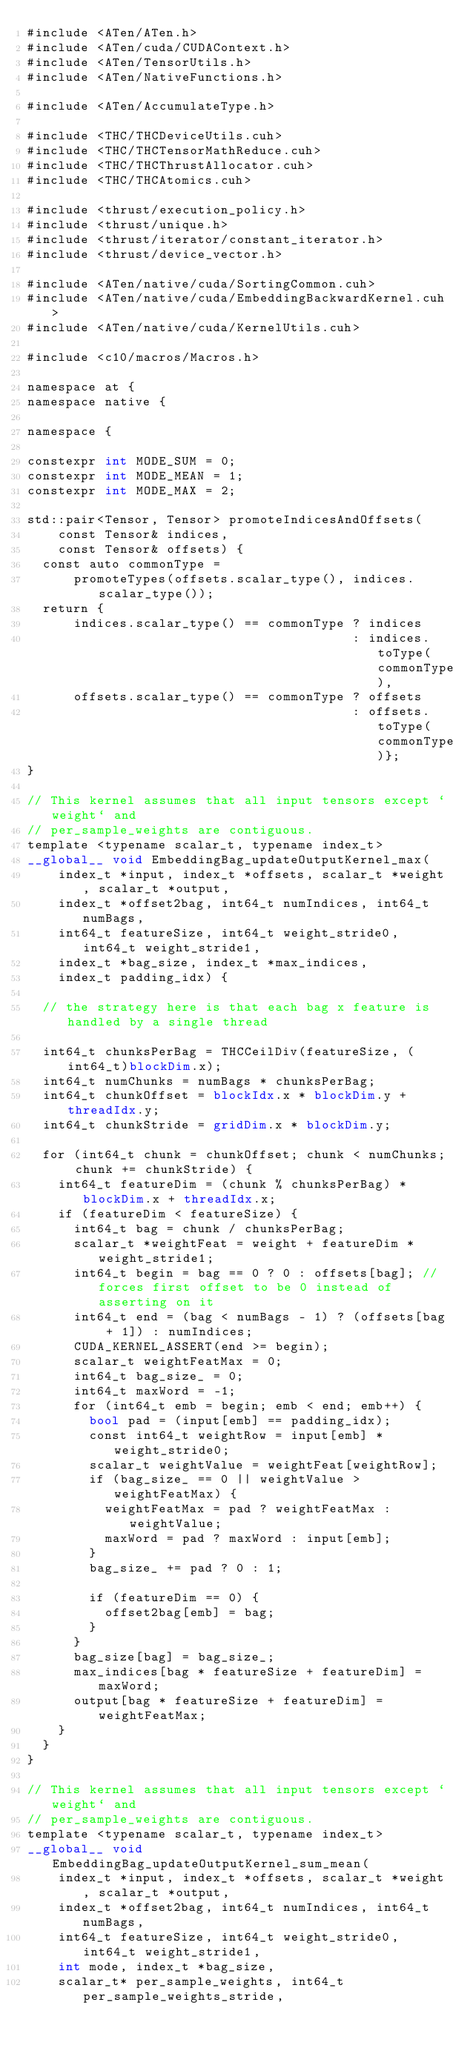<code> <loc_0><loc_0><loc_500><loc_500><_Cuda_>#include <ATen/ATen.h>
#include <ATen/cuda/CUDAContext.h>
#include <ATen/TensorUtils.h>
#include <ATen/NativeFunctions.h>

#include <ATen/AccumulateType.h>

#include <THC/THCDeviceUtils.cuh>
#include <THC/THCTensorMathReduce.cuh>
#include <THC/THCThrustAllocator.cuh>
#include <THC/THCAtomics.cuh>

#include <thrust/execution_policy.h>
#include <thrust/unique.h>
#include <thrust/iterator/constant_iterator.h>
#include <thrust/device_vector.h>

#include <ATen/native/cuda/SortingCommon.cuh>
#include <ATen/native/cuda/EmbeddingBackwardKernel.cuh>
#include <ATen/native/cuda/KernelUtils.cuh>

#include <c10/macros/Macros.h>

namespace at {
namespace native {

namespace {

constexpr int MODE_SUM = 0;
constexpr int MODE_MEAN = 1;
constexpr int MODE_MAX = 2;

std::pair<Tensor, Tensor> promoteIndicesAndOffsets(
    const Tensor& indices,
    const Tensor& offsets) {
  const auto commonType =
      promoteTypes(offsets.scalar_type(), indices.scalar_type());
  return {
      indices.scalar_type() == commonType ? indices
                                          : indices.toType(commonType),
      offsets.scalar_type() == commonType ? offsets
                                          : offsets.toType(commonType)};
}

// This kernel assumes that all input tensors except `weight` and
// per_sample_weights are contiguous.
template <typename scalar_t, typename index_t>
__global__ void EmbeddingBag_updateOutputKernel_max(
    index_t *input, index_t *offsets, scalar_t *weight, scalar_t *output,
    index_t *offset2bag, int64_t numIndices, int64_t numBags,
    int64_t featureSize, int64_t weight_stride0, int64_t weight_stride1,
    index_t *bag_size, index_t *max_indices,
    index_t padding_idx) {

  // the strategy here is that each bag x feature is handled by a single thread

  int64_t chunksPerBag = THCCeilDiv(featureSize, (int64_t)blockDim.x);
  int64_t numChunks = numBags * chunksPerBag;
  int64_t chunkOffset = blockIdx.x * blockDim.y + threadIdx.y;
  int64_t chunkStride = gridDim.x * blockDim.y;

  for (int64_t chunk = chunkOffset; chunk < numChunks; chunk += chunkStride) {
    int64_t featureDim = (chunk % chunksPerBag) * blockDim.x + threadIdx.x;
    if (featureDim < featureSize) {
      int64_t bag = chunk / chunksPerBag;
      scalar_t *weightFeat = weight + featureDim * weight_stride1;
      int64_t begin = bag == 0 ? 0 : offsets[bag]; // forces first offset to be 0 instead of asserting on it
      int64_t end = (bag < numBags - 1) ? (offsets[bag + 1]) : numIndices;
      CUDA_KERNEL_ASSERT(end >= begin);
      scalar_t weightFeatMax = 0;
      int64_t bag_size_ = 0;
      int64_t maxWord = -1;
      for (int64_t emb = begin; emb < end; emb++) {
        bool pad = (input[emb] == padding_idx);
        const int64_t weightRow = input[emb] * weight_stride0;
        scalar_t weightValue = weightFeat[weightRow];
        if (bag_size_ == 0 || weightValue > weightFeatMax) {
          weightFeatMax = pad ? weightFeatMax : weightValue;
          maxWord = pad ? maxWord : input[emb];
        }
        bag_size_ += pad ? 0 : 1;

        if (featureDim == 0) {
          offset2bag[emb] = bag;
        }
      }
      bag_size[bag] = bag_size_;
      max_indices[bag * featureSize + featureDim] = maxWord;
      output[bag * featureSize + featureDim] = weightFeatMax;
    }
  }
}

// This kernel assumes that all input tensors except `weight` and
// per_sample_weights are contiguous.
template <typename scalar_t, typename index_t>
__global__ void EmbeddingBag_updateOutputKernel_sum_mean(
    index_t *input, index_t *offsets, scalar_t *weight, scalar_t *output,
    index_t *offset2bag, int64_t numIndices, int64_t numBags,
    int64_t featureSize, int64_t weight_stride0, int64_t weight_stride1,
    int mode, index_t *bag_size,
    scalar_t* per_sample_weights, int64_t per_sample_weights_stride,</code> 